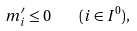<formula> <loc_0><loc_0><loc_500><loc_500>m ^ { \prime } _ { i } \leq 0 \quad ( i \in I ^ { 0 } ) ,</formula> 